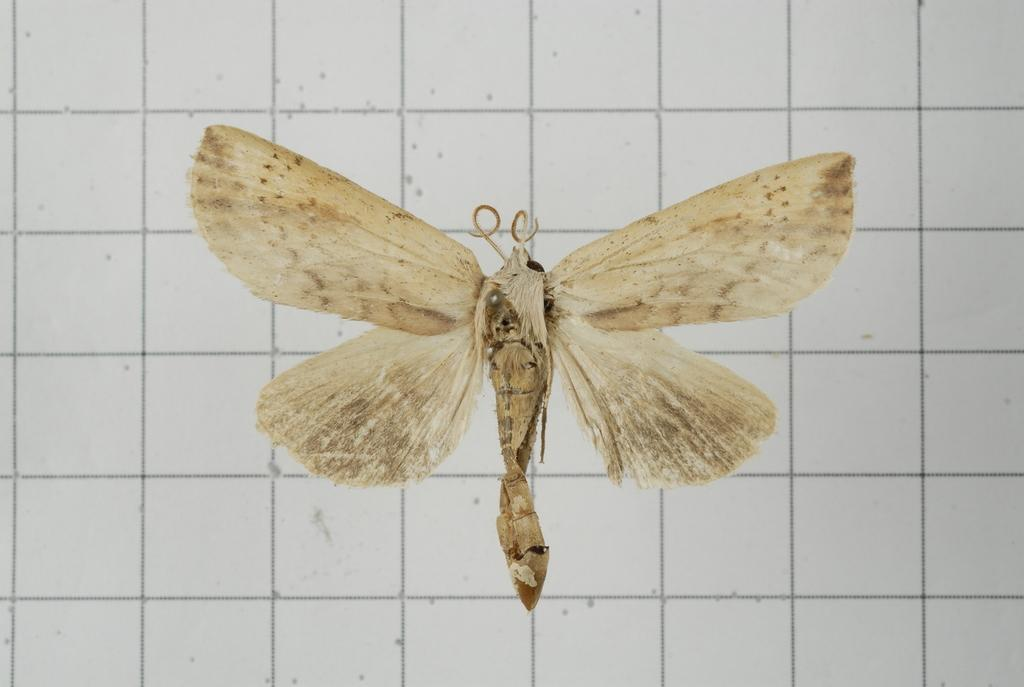What is the main subject of the image? There is a dragonfly in the image. Can you describe the background of the image? There is a background in the image, but specific details are not provided. Is there a receipt visible in the image? There is no mention of a receipt in the provided facts, so it cannot be determined if one is present in the image. 